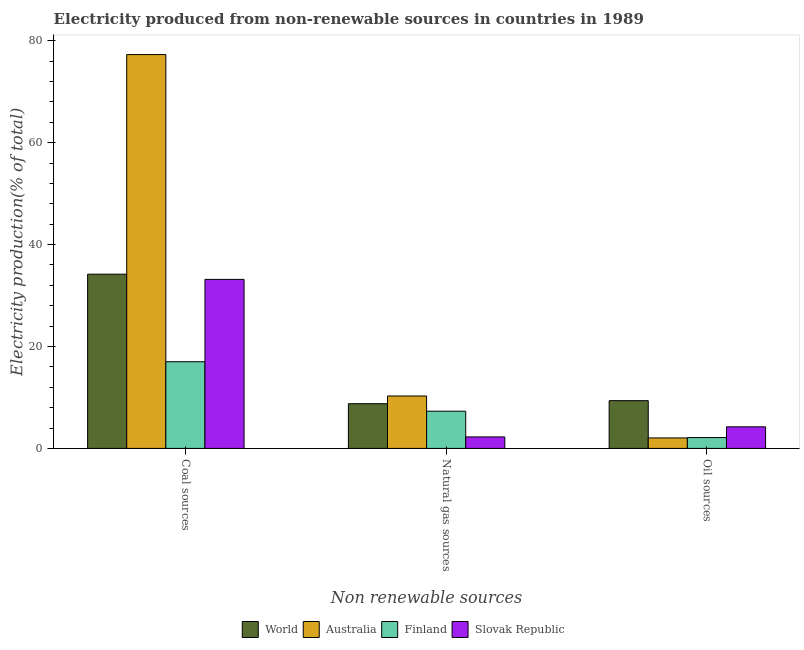How many groups of bars are there?
Your answer should be very brief. 3. What is the label of the 3rd group of bars from the left?
Your answer should be very brief. Oil sources. What is the percentage of electricity produced by oil sources in Australia?
Your response must be concise. 2.06. Across all countries, what is the maximum percentage of electricity produced by natural gas?
Your response must be concise. 10.29. Across all countries, what is the minimum percentage of electricity produced by coal?
Give a very brief answer. 17.01. In which country was the percentage of electricity produced by coal maximum?
Offer a terse response. Australia. In which country was the percentage of electricity produced by natural gas minimum?
Your answer should be very brief. Slovak Republic. What is the total percentage of electricity produced by natural gas in the graph?
Ensure brevity in your answer.  28.62. What is the difference between the percentage of electricity produced by coal in Slovak Republic and that in World?
Ensure brevity in your answer.  -1.02. What is the difference between the percentage of electricity produced by oil sources in World and the percentage of electricity produced by natural gas in Finland?
Offer a very short reply. 2.06. What is the average percentage of electricity produced by natural gas per country?
Give a very brief answer. 7.15. What is the difference between the percentage of electricity produced by coal and percentage of electricity produced by oil sources in Slovak Republic?
Provide a succinct answer. 28.93. What is the ratio of the percentage of electricity produced by coal in Finland to that in Australia?
Offer a terse response. 0.22. Is the percentage of electricity produced by oil sources in World less than that in Finland?
Offer a very short reply. No. What is the difference between the highest and the second highest percentage of electricity produced by natural gas?
Provide a short and direct response. 1.51. What is the difference between the highest and the lowest percentage of electricity produced by oil sources?
Offer a terse response. 7.31. Is the sum of the percentage of electricity produced by coal in Finland and Slovak Republic greater than the maximum percentage of electricity produced by oil sources across all countries?
Provide a succinct answer. Yes. What does the 2nd bar from the right in Coal sources represents?
Your response must be concise. Finland. Is it the case that in every country, the sum of the percentage of electricity produced by coal and percentage of electricity produced by natural gas is greater than the percentage of electricity produced by oil sources?
Offer a terse response. Yes. How many bars are there?
Give a very brief answer. 12. Are all the bars in the graph horizontal?
Provide a succinct answer. No. What is the difference between two consecutive major ticks on the Y-axis?
Give a very brief answer. 20. Are the values on the major ticks of Y-axis written in scientific E-notation?
Make the answer very short. No. How many legend labels are there?
Provide a succinct answer. 4. How are the legend labels stacked?
Your answer should be compact. Horizontal. What is the title of the graph?
Offer a very short reply. Electricity produced from non-renewable sources in countries in 1989. Does "Upper middle income" appear as one of the legend labels in the graph?
Your response must be concise. No. What is the label or title of the X-axis?
Give a very brief answer. Non renewable sources. What is the Electricity production(% of total) in World in Coal sources?
Keep it short and to the point. 34.19. What is the Electricity production(% of total) in Australia in Coal sources?
Make the answer very short. 77.28. What is the Electricity production(% of total) in Finland in Coal sources?
Your answer should be very brief. 17.01. What is the Electricity production(% of total) in Slovak Republic in Coal sources?
Your response must be concise. 33.17. What is the Electricity production(% of total) in World in Natural gas sources?
Give a very brief answer. 8.77. What is the Electricity production(% of total) in Australia in Natural gas sources?
Provide a short and direct response. 10.29. What is the Electricity production(% of total) in Finland in Natural gas sources?
Provide a succinct answer. 7.3. What is the Electricity production(% of total) of Slovak Republic in Natural gas sources?
Keep it short and to the point. 2.26. What is the Electricity production(% of total) of World in Oil sources?
Provide a short and direct response. 9.37. What is the Electricity production(% of total) of Australia in Oil sources?
Keep it short and to the point. 2.06. What is the Electricity production(% of total) in Finland in Oil sources?
Your answer should be compact. 2.13. What is the Electricity production(% of total) of Slovak Republic in Oil sources?
Your answer should be very brief. 4.24. Across all Non renewable sources, what is the maximum Electricity production(% of total) in World?
Give a very brief answer. 34.19. Across all Non renewable sources, what is the maximum Electricity production(% of total) of Australia?
Your answer should be compact. 77.28. Across all Non renewable sources, what is the maximum Electricity production(% of total) in Finland?
Your answer should be compact. 17.01. Across all Non renewable sources, what is the maximum Electricity production(% of total) in Slovak Republic?
Your response must be concise. 33.17. Across all Non renewable sources, what is the minimum Electricity production(% of total) of World?
Your answer should be very brief. 8.77. Across all Non renewable sources, what is the minimum Electricity production(% of total) of Australia?
Offer a very short reply. 2.06. Across all Non renewable sources, what is the minimum Electricity production(% of total) in Finland?
Your response must be concise. 2.13. Across all Non renewable sources, what is the minimum Electricity production(% of total) in Slovak Republic?
Your answer should be very brief. 2.26. What is the total Electricity production(% of total) in World in the graph?
Ensure brevity in your answer.  52.33. What is the total Electricity production(% of total) of Australia in the graph?
Ensure brevity in your answer.  89.62. What is the total Electricity production(% of total) of Finland in the graph?
Make the answer very short. 26.44. What is the total Electricity production(% of total) in Slovak Republic in the graph?
Keep it short and to the point. 39.66. What is the difference between the Electricity production(% of total) in World in Coal sources and that in Natural gas sources?
Keep it short and to the point. 25.42. What is the difference between the Electricity production(% of total) of Australia in Coal sources and that in Natural gas sources?
Offer a terse response. 66.99. What is the difference between the Electricity production(% of total) of Finland in Coal sources and that in Natural gas sources?
Offer a terse response. 9.7. What is the difference between the Electricity production(% of total) of Slovak Republic in Coal sources and that in Natural gas sources?
Your answer should be compact. 30.91. What is the difference between the Electricity production(% of total) of World in Coal sources and that in Oil sources?
Keep it short and to the point. 24.82. What is the difference between the Electricity production(% of total) of Australia in Coal sources and that in Oil sources?
Provide a succinct answer. 75.22. What is the difference between the Electricity production(% of total) of Finland in Coal sources and that in Oil sources?
Offer a very short reply. 14.87. What is the difference between the Electricity production(% of total) of Slovak Republic in Coal sources and that in Oil sources?
Make the answer very short. 28.93. What is the difference between the Electricity production(% of total) of World in Natural gas sources and that in Oil sources?
Your response must be concise. -0.6. What is the difference between the Electricity production(% of total) in Australia in Natural gas sources and that in Oil sources?
Ensure brevity in your answer.  8.23. What is the difference between the Electricity production(% of total) of Finland in Natural gas sources and that in Oil sources?
Make the answer very short. 5.17. What is the difference between the Electricity production(% of total) in Slovak Republic in Natural gas sources and that in Oil sources?
Your answer should be compact. -1.98. What is the difference between the Electricity production(% of total) of World in Coal sources and the Electricity production(% of total) of Australia in Natural gas sources?
Provide a succinct answer. 23.9. What is the difference between the Electricity production(% of total) of World in Coal sources and the Electricity production(% of total) of Finland in Natural gas sources?
Offer a terse response. 26.88. What is the difference between the Electricity production(% of total) of World in Coal sources and the Electricity production(% of total) of Slovak Republic in Natural gas sources?
Your response must be concise. 31.93. What is the difference between the Electricity production(% of total) of Australia in Coal sources and the Electricity production(% of total) of Finland in Natural gas sources?
Offer a very short reply. 69.98. What is the difference between the Electricity production(% of total) in Australia in Coal sources and the Electricity production(% of total) in Slovak Republic in Natural gas sources?
Your answer should be compact. 75.02. What is the difference between the Electricity production(% of total) of Finland in Coal sources and the Electricity production(% of total) of Slovak Republic in Natural gas sources?
Provide a short and direct response. 14.75. What is the difference between the Electricity production(% of total) of World in Coal sources and the Electricity production(% of total) of Australia in Oil sources?
Give a very brief answer. 32.13. What is the difference between the Electricity production(% of total) in World in Coal sources and the Electricity production(% of total) in Finland in Oil sources?
Make the answer very short. 32.06. What is the difference between the Electricity production(% of total) in World in Coal sources and the Electricity production(% of total) in Slovak Republic in Oil sources?
Your answer should be very brief. 29.95. What is the difference between the Electricity production(% of total) in Australia in Coal sources and the Electricity production(% of total) in Finland in Oil sources?
Offer a terse response. 75.15. What is the difference between the Electricity production(% of total) in Australia in Coal sources and the Electricity production(% of total) in Slovak Republic in Oil sources?
Make the answer very short. 73.04. What is the difference between the Electricity production(% of total) in Finland in Coal sources and the Electricity production(% of total) in Slovak Republic in Oil sources?
Provide a succinct answer. 12.77. What is the difference between the Electricity production(% of total) of World in Natural gas sources and the Electricity production(% of total) of Australia in Oil sources?
Provide a succinct answer. 6.72. What is the difference between the Electricity production(% of total) of World in Natural gas sources and the Electricity production(% of total) of Finland in Oil sources?
Your response must be concise. 6.64. What is the difference between the Electricity production(% of total) in World in Natural gas sources and the Electricity production(% of total) in Slovak Republic in Oil sources?
Keep it short and to the point. 4.53. What is the difference between the Electricity production(% of total) of Australia in Natural gas sources and the Electricity production(% of total) of Finland in Oil sources?
Offer a terse response. 8.15. What is the difference between the Electricity production(% of total) in Australia in Natural gas sources and the Electricity production(% of total) in Slovak Republic in Oil sources?
Keep it short and to the point. 6.05. What is the difference between the Electricity production(% of total) in Finland in Natural gas sources and the Electricity production(% of total) in Slovak Republic in Oil sources?
Ensure brevity in your answer.  3.07. What is the average Electricity production(% of total) in World per Non renewable sources?
Offer a very short reply. 17.44. What is the average Electricity production(% of total) of Australia per Non renewable sources?
Offer a terse response. 29.87. What is the average Electricity production(% of total) in Finland per Non renewable sources?
Provide a short and direct response. 8.81. What is the average Electricity production(% of total) in Slovak Republic per Non renewable sources?
Your response must be concise. 13.22. What is the difference between the Electricity production(% of total) in World and Electricity production(% of total) in Australia in Coal sources?
Your answer should be very brief. -43.09. What is the difference between the Electricity production(% of total) in World and Electricity production(% of total) in Finland in Coal sources?
Provide a succinct answer. 17.18. What is the difference between the Electricity production(% of total) of World and Electricity production(% of total) of Slovak Republic in Coal sources?
Offer a very short reply. 1.02. What is the difference between the Electricity production(% of total) of Australia and Electricity production(% of total) of Finland in Coal sources?
Make the answer very short. 60.27. What is the difference between the Electricity production(% of total) in Australia and Electricity production(% of total) in Slovak Republic in Coal sources?
Make the answer very short. 44.11. What is the difference between the Electricity production(% of total) of Finland and Electricity production(% of total) of Slovak Republic in Coal sources?
Offer a very short reply. -16.16. What is the difference between the Electricity production(% of total) of World and Electricity production(% of total) of Australia in Natural gas sources?
Ensure brevity in your answer.  -1.51. What is the difference between the Electricity production(% of total) of World and Electricity production(% of total) of Finland in Natural gas sources?
Your answer should be compact. 1.47. What is the difference between the Electricity production(% of total) in World and Electricity production(% of total) in Slovak Republic in Natural gas sources?
Provide a short and direct response. 6.51. What is the difference between the Electricity production(% of total) of Australia and Electricity production(% of total) of Finland in Natural gas sources?
Give a very brief answer. 2.98. What is the difference between the Electricity production(% of total) of Australia and Electricity production(% of total) of Slovak Republic in Natural gas sources?
Your answer should be compact. 8.03. What is the difference between the Electricity production(% of total) in Finland and Electricity production(% of total) in Slovak Republic in Natural gas sources?
Provide a short and direct response. 5.05. What is the difference between the Electricity production(% of total) in World and Electricity production(% of total) in Australia in Oil sources?
Make the answer very short. 7.31. What is the difference between the Electricity production(% of total) in World and Electricity production(% of total) in Finland in Oil sources?
Provide a short and direct response. 7.24. What is the difference between the Electricity production(% of total) in World and Electricity production(% of total) in Slovak Republic in Oil sources?
Offer a terse response. 5.13. What is the difference between the Electricity production(% of total) in Australia and Electricity production(% of total) in Finland in Oil sources?
Your answer should be very brief. -0.08. What is the difference between the Electricity production(% of total) of Australia and Electricity production(% of total) of Slovak Republic in Oil sources?
Provide a short and direct response. -2.18. What is the difference between the Electricity production(% of total) in Finland and Electricity production(% of total) in Slovak Republic in Oil sources?
Your answer should be very brief. -2.11. What is the ratio of the Electricity production(% of total) in World in Coal sources to that in Natural gas sources?
Give a very brief answer. 3.9. What is the ratio of the Electricity production(% of total) of Australia in Coal sources to that in Natural gas sources?
Your answer should be compact. 7.51. What is the ratio of the Electricity production(% of total) in Finland in Coal sources to that in Natural gas sources?
Provide a succinct answer. 2.33. What is the ratio of the Electricity production(% of total) of Slovak Republic in Coal sources to that in Natural gas sources?
Offer a terse response. 14.7. What is the ratio of the Electricity production(% of total) in World in Coal sources to that in Oil sources?
Offer a terse response. 3.65. What is the ratio of the Electricity production(% of total) in Australia in Coal sources to that in Oil sources?
Provide a short and direct response. 37.59. What is the ratio of the Electricity production(% of total) in Finland in Coal sources to that in Oil sources?
Offer a terse response. 7.98. What is the ratio of the Electricity production(% of total) in Slovak Republic in Coal sources to that in Oil sources?
Keep it short and to the point. 7.82. What is the ratio of the Electricity production(% of total) in World in Natural gas sources to that in Oil sources?
Make the answer very short. 0.94. What is the ratio of the Electricity production(% of total) of Australia in Natural gas sources to that in Oil sources?
Provide a succinct answer. 5. What is the ratio of the Electricity production(% of total) of Finland in Natural gas sources to that in Oil sources?
Offer a terse response. 3.43. What is the ratio of the Electricity production(% of total) in Slovak Republic in Natural gas sources to that in Oil sources?
Keep it short and to the point. 0.53. What is the difference between the highest and the second highest Electricity production(% of total) of World?
Offer a terse response. 24.82. What is the difference between the highest and the second highest Electricity production(% of total) in Australia?
Your answer should be compact. 66.99. What is the difference between the highest and the second highest Electricity production(% of total) in Finland?
Your answer should be compact. 9.7. What is the difference between the highest and the second highest Electricity production(% of total) in Slovak Republic?
Make the answer very short. 28.93. What is the difference between the highest and the lowest Electricity production(% of total) in World?
Ensure brevity in your answer.  25.42. What is the difference between the highest and the lowest Electricity production(% of total) in Australia?
Ensure brevity in your answer.  75.22. What is the difference between the highest and the lowest Electricity production(% of total) in Finland?
Make the answer very short. 14.87. What is the difference between the highest and the lowest Electricity production(% of total) of Slovak Republic?
Make the answer very short. 30.91. 